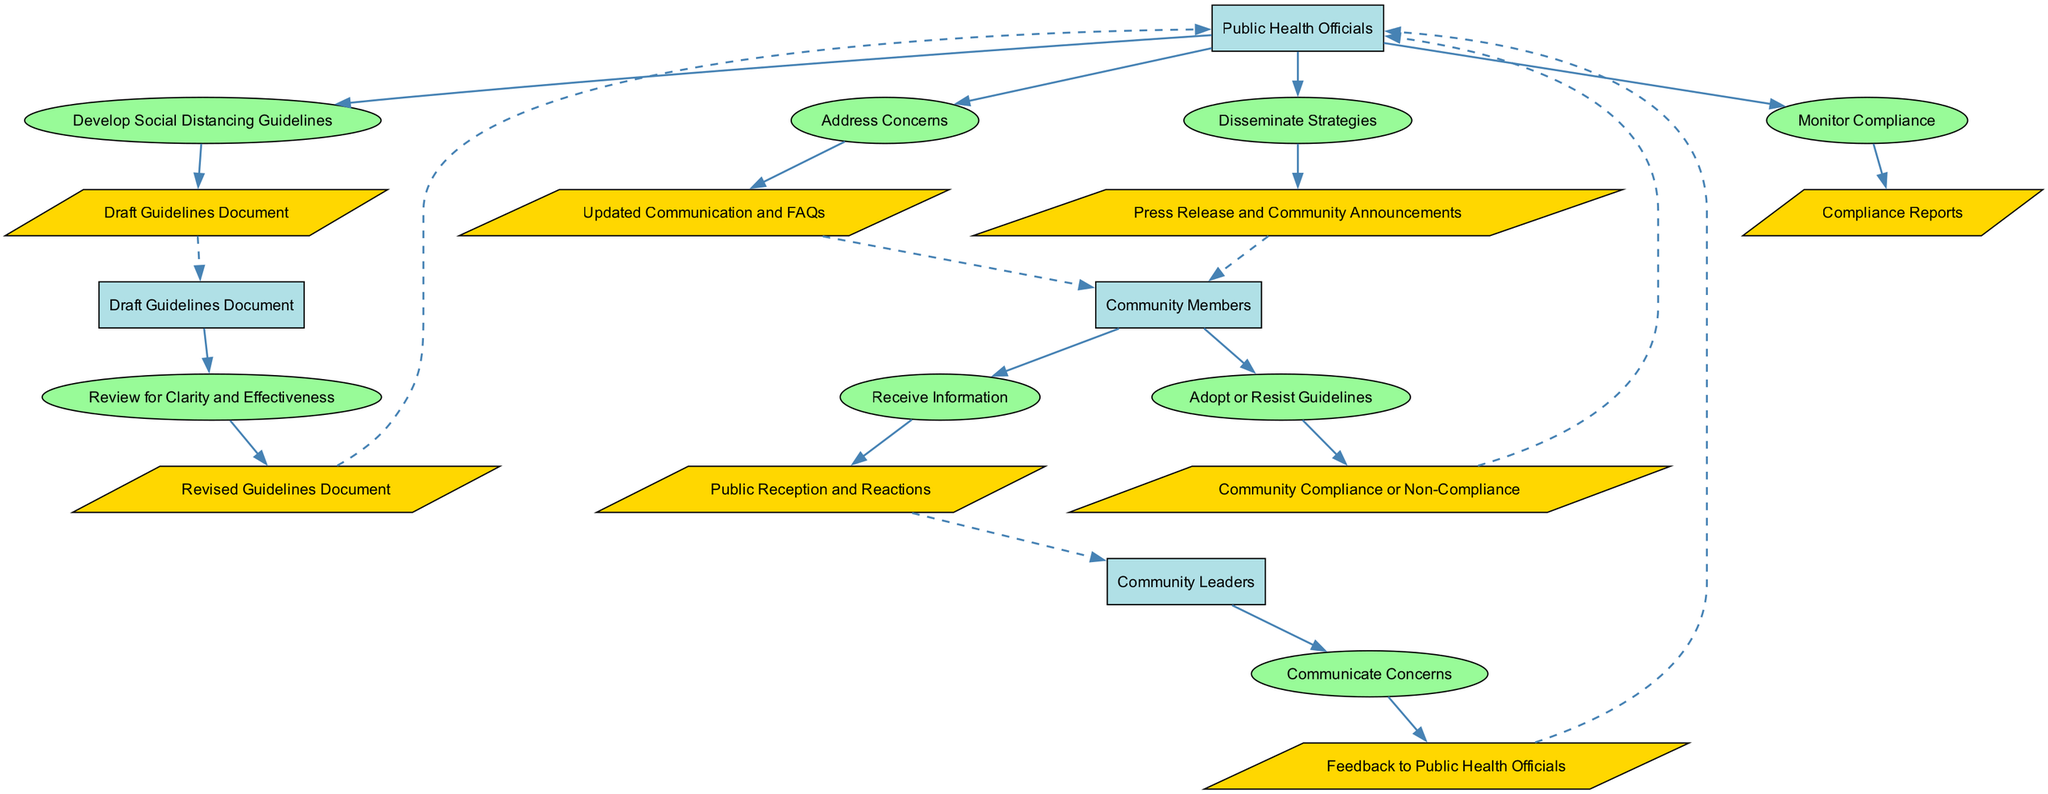What is the first action taken by Public Health Officials? The diagram indicates that the first action performed by Public Health Officials is to "Develop Social Distancing Guidelines." This is derived from the first element of the sequence diagram.
Answer: Develop Social Distancing Guidelines What output results from the review process? According to the sequence, after Public Health Officials review the guidelines for clarity and effectiveness, the output is "Revised Guidelines Document." This is explicitly stated as the result of that action.
Answer: Revised Guidelines Document How many entities are involved in the communication process? The elements in the diagram show that there are five distinct entities: Public Health Officials, Draft Guidelines Document, Community Members, Community Leaders, and Compliance Reports. Counting each unique entity gives us a total of five.
Answer: Five What feedback is communicated to Public Health Officials? The diagram specifies that Community Leaders communicate "Concerns," which represents the feedback they provide back to Public Health Officials. This reflects the interaction between the community and public health officials.
Answer: Concerns What happens after Community Members adopt the guidelines? According to the diagram, the next step after Community Members adopt the guidelines is that the output reflects "Community Compliance." This indicates a successful acceptance of the guidelines by the community.
Answer: Community Compliance How do Public Health Officials address concerns raised? Public Health Officials respond to the communicated concerns by providing "Updated Communication and FAQs." This action indicates their effort to clarify and provide additional information following community feedback.
Answer: Updated Communication and FAQs Which entity monitors compliance? The diagram shows that the responsibility for monitoring compliance lies with the Public Health Officials. This is clearly indicated as an action that follows the community's adoption of the guidelines.
Answer: Public Health Officials What type of documents are produced during the guideline development process? During the guideline development process, the output documents include the "Draft Guidelines Document" initially, which afterward gets revised into the "Revised Guidelines Document." This step highlights the iterative nature of document creation.
Answer: Draft Guidelines Document What label is used on the edge connecting the action of disseminating strategies? The edge from the "Disseminate Strategies" action does not have an explicit label attached, as indicated in the diagram. It serves as a straightforward connection to the next phase of the communication flow.
Answer: None 